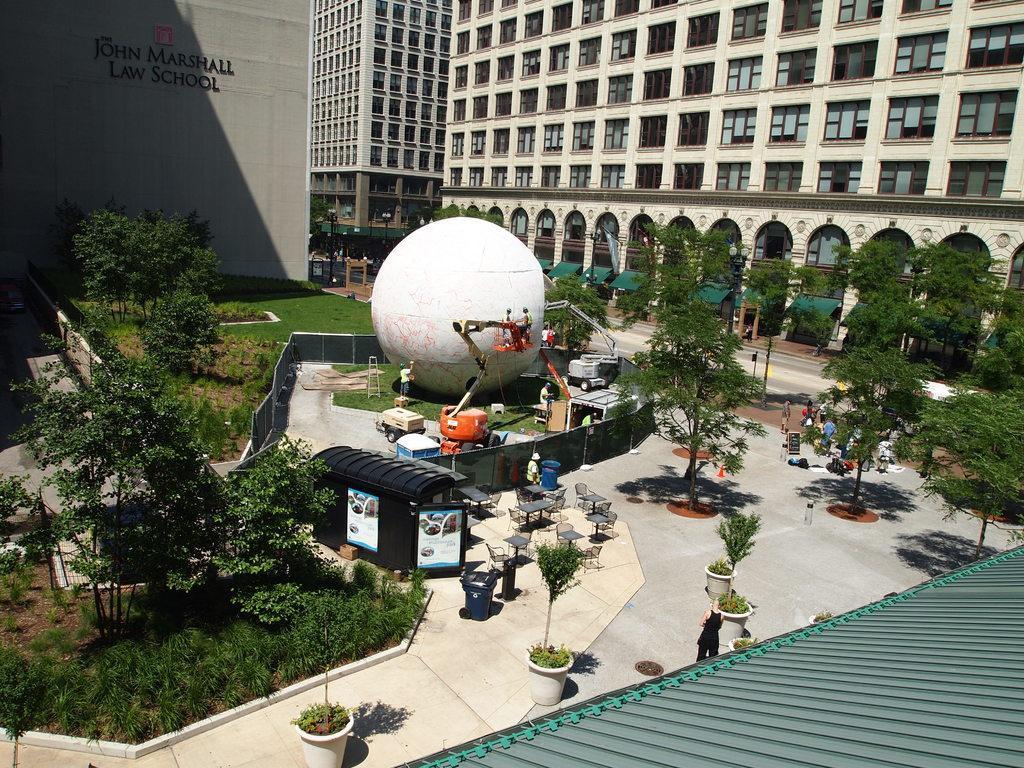How would you summarize this image in a sentence or two? In this image in an open area there are trees, potted plants, machines, chairs, tables, dustbin, cabin, few other things are there. In the background there are buildings, street lights. Here there is a road. 